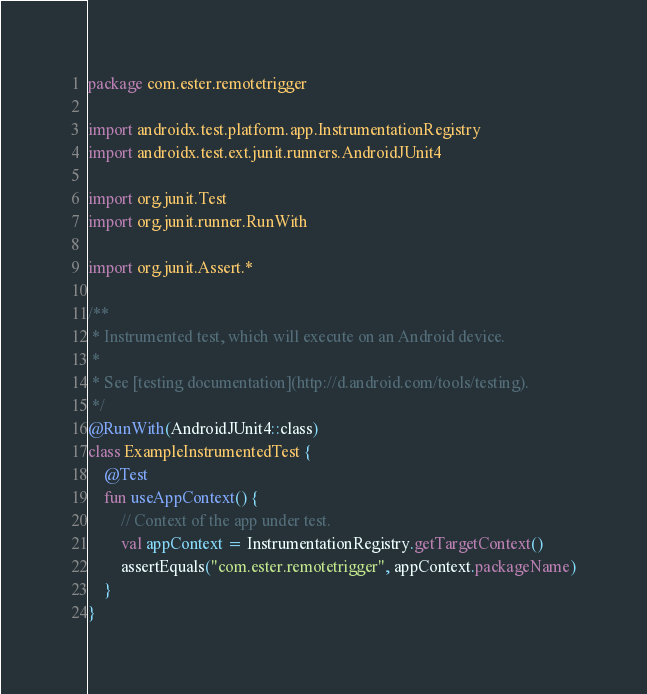Convert code to text. <code><loc_0><loc_0><loc_500><loc_500><_Kotlin_>package com.ester.remotetrigger

import androidx.test.platform.app.InstrumentationRegistry
import androidx.test.ext.junit.runners.AndroidJUnit4

import org.junit.Test
import org.junit.runner.RunWith

import org.junit.Assert.*

/**
 * Instrumented test, which will execute on an Android device.
 *
 * See [testing documentation](http://d.android.com/tools/testing).
 */
@RunWith(AndroidJUnit4::class)
class ExampleInstrumentedTest {
    @Test
    fun useAppContext() {
        // Context of the app under test.
        val appContext = InstrumentationRegistry.getTargetContext()
        assertEquals("com.ester.remotetrigger", appContext.packageName)
    }
}
</code> 